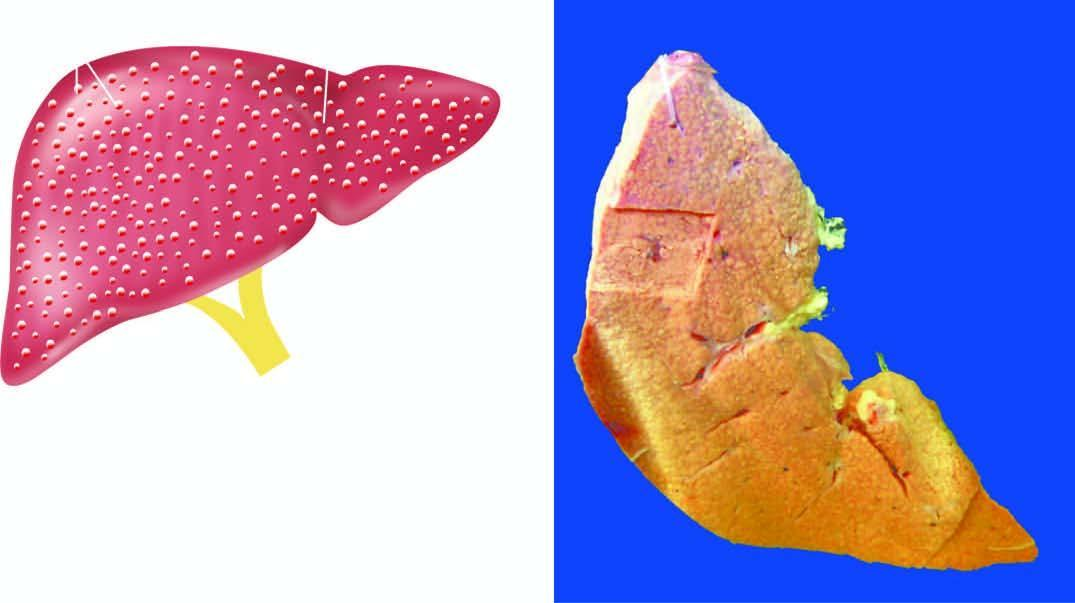what is there on sectioned surface of the liver?
Answer the question using a single word or phrase. Diffuse nodularity 